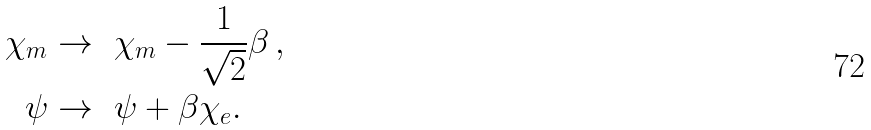<formula> <loc_0><loc_0><loc_500><loc_500>\chi _ { m } & \rightarrow \ \chi _ { m } - \frac { 1 } { \sqrt { 2 } } \beta \, , \\ \psi & \rightarrow \ \psi + \beta \chi _ { e } .</formula> 